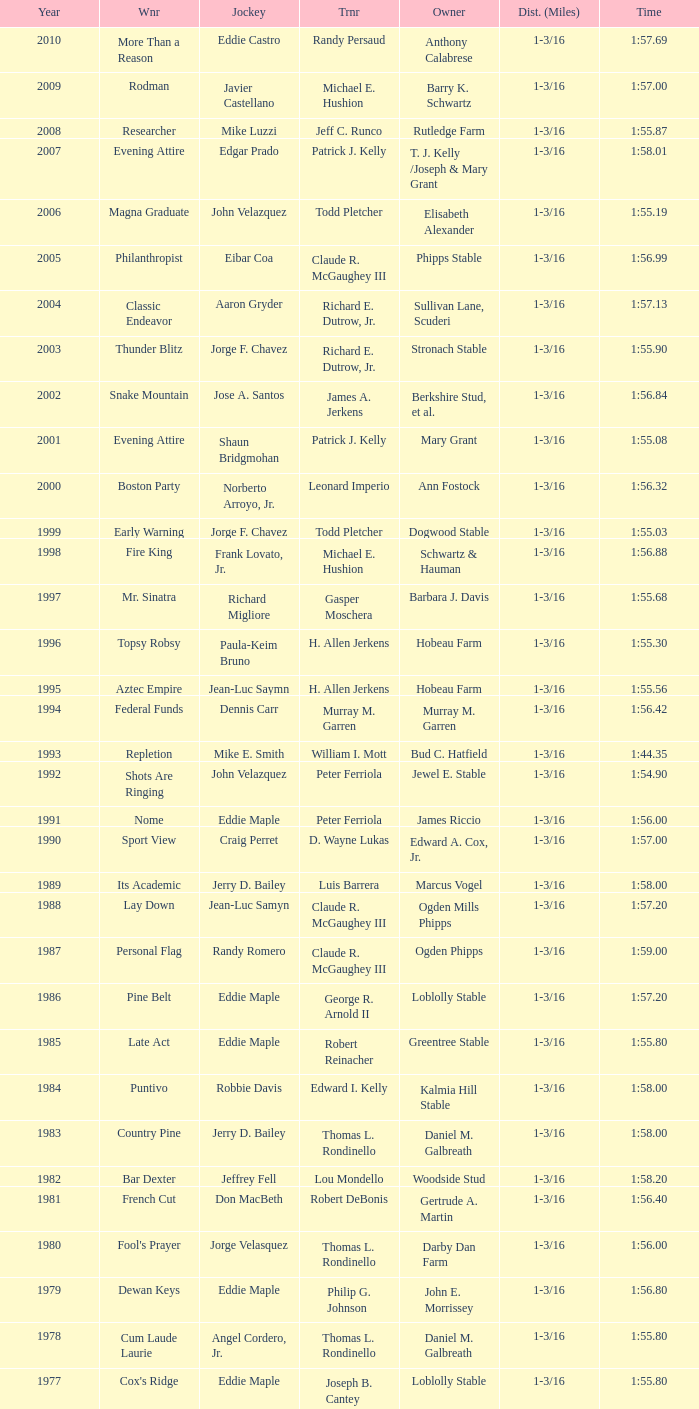When the winner was No Race in a year after 1909, what was the distance? 1 mile, 1 mile, 1 mile. 